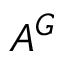<formula> <loc_0><loc_0><loc_500><loc_500>A ^ { G }</formula> 